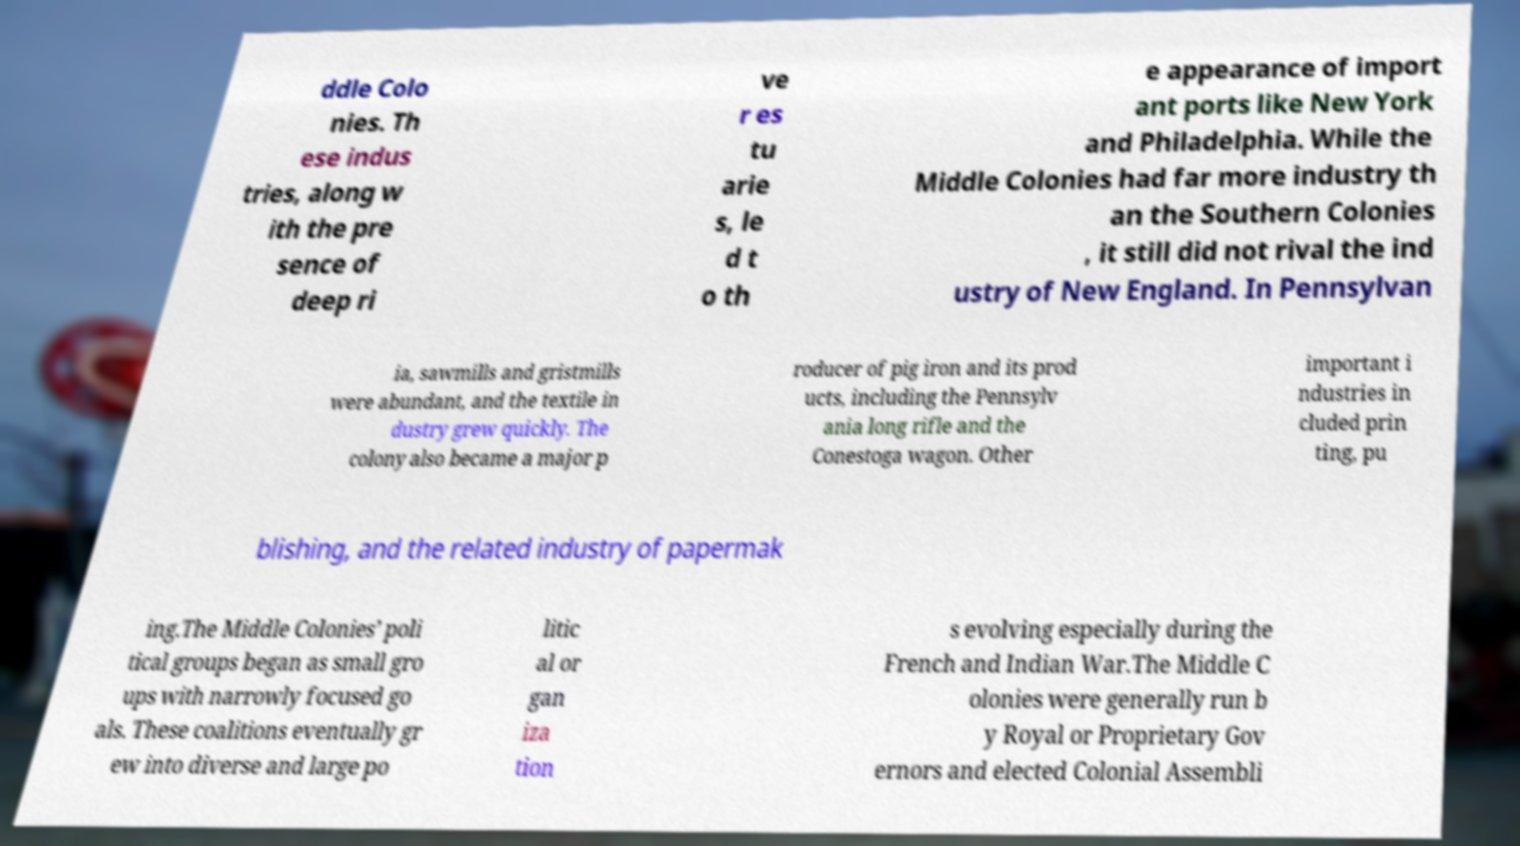I need the written content from this picture converted into text. Can you do that? ddle Colo nies. Th ese indus tries, along w ith the pre sence of deep ri ve r es tu arie s, le d t o th e appearance of import ant ports like New York and Philadelphia. While the Middle Colonies had far more industry th an the Southern Colonies , it still did not rival the ind ustry of New England. In Pennsylvan ia, sawmills and gristmills were abundant, and the textile in dustry grew quickly. The colony also became a major p roducer of pig iron and its prod ucts, including the Pennsylv ania long rifle and the Conestoga wagon. Other important i ndustries in cluded prin ting, pu blishing, and the related industry of papermak ing.The Middle Colonies’ poli tical groups began as small gro ups with narrowly focused go als. These coalitions eventually gr ew into diverse and large po litic al or gan iza tion s evolving especially during the French and Indian War.The Middle C olonies were generally run b y Royal or Proprietary Gov ernors and elected Colonial Assembli 